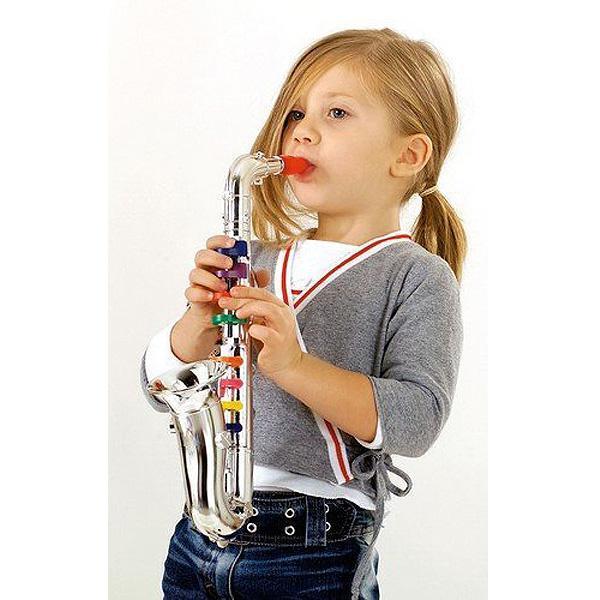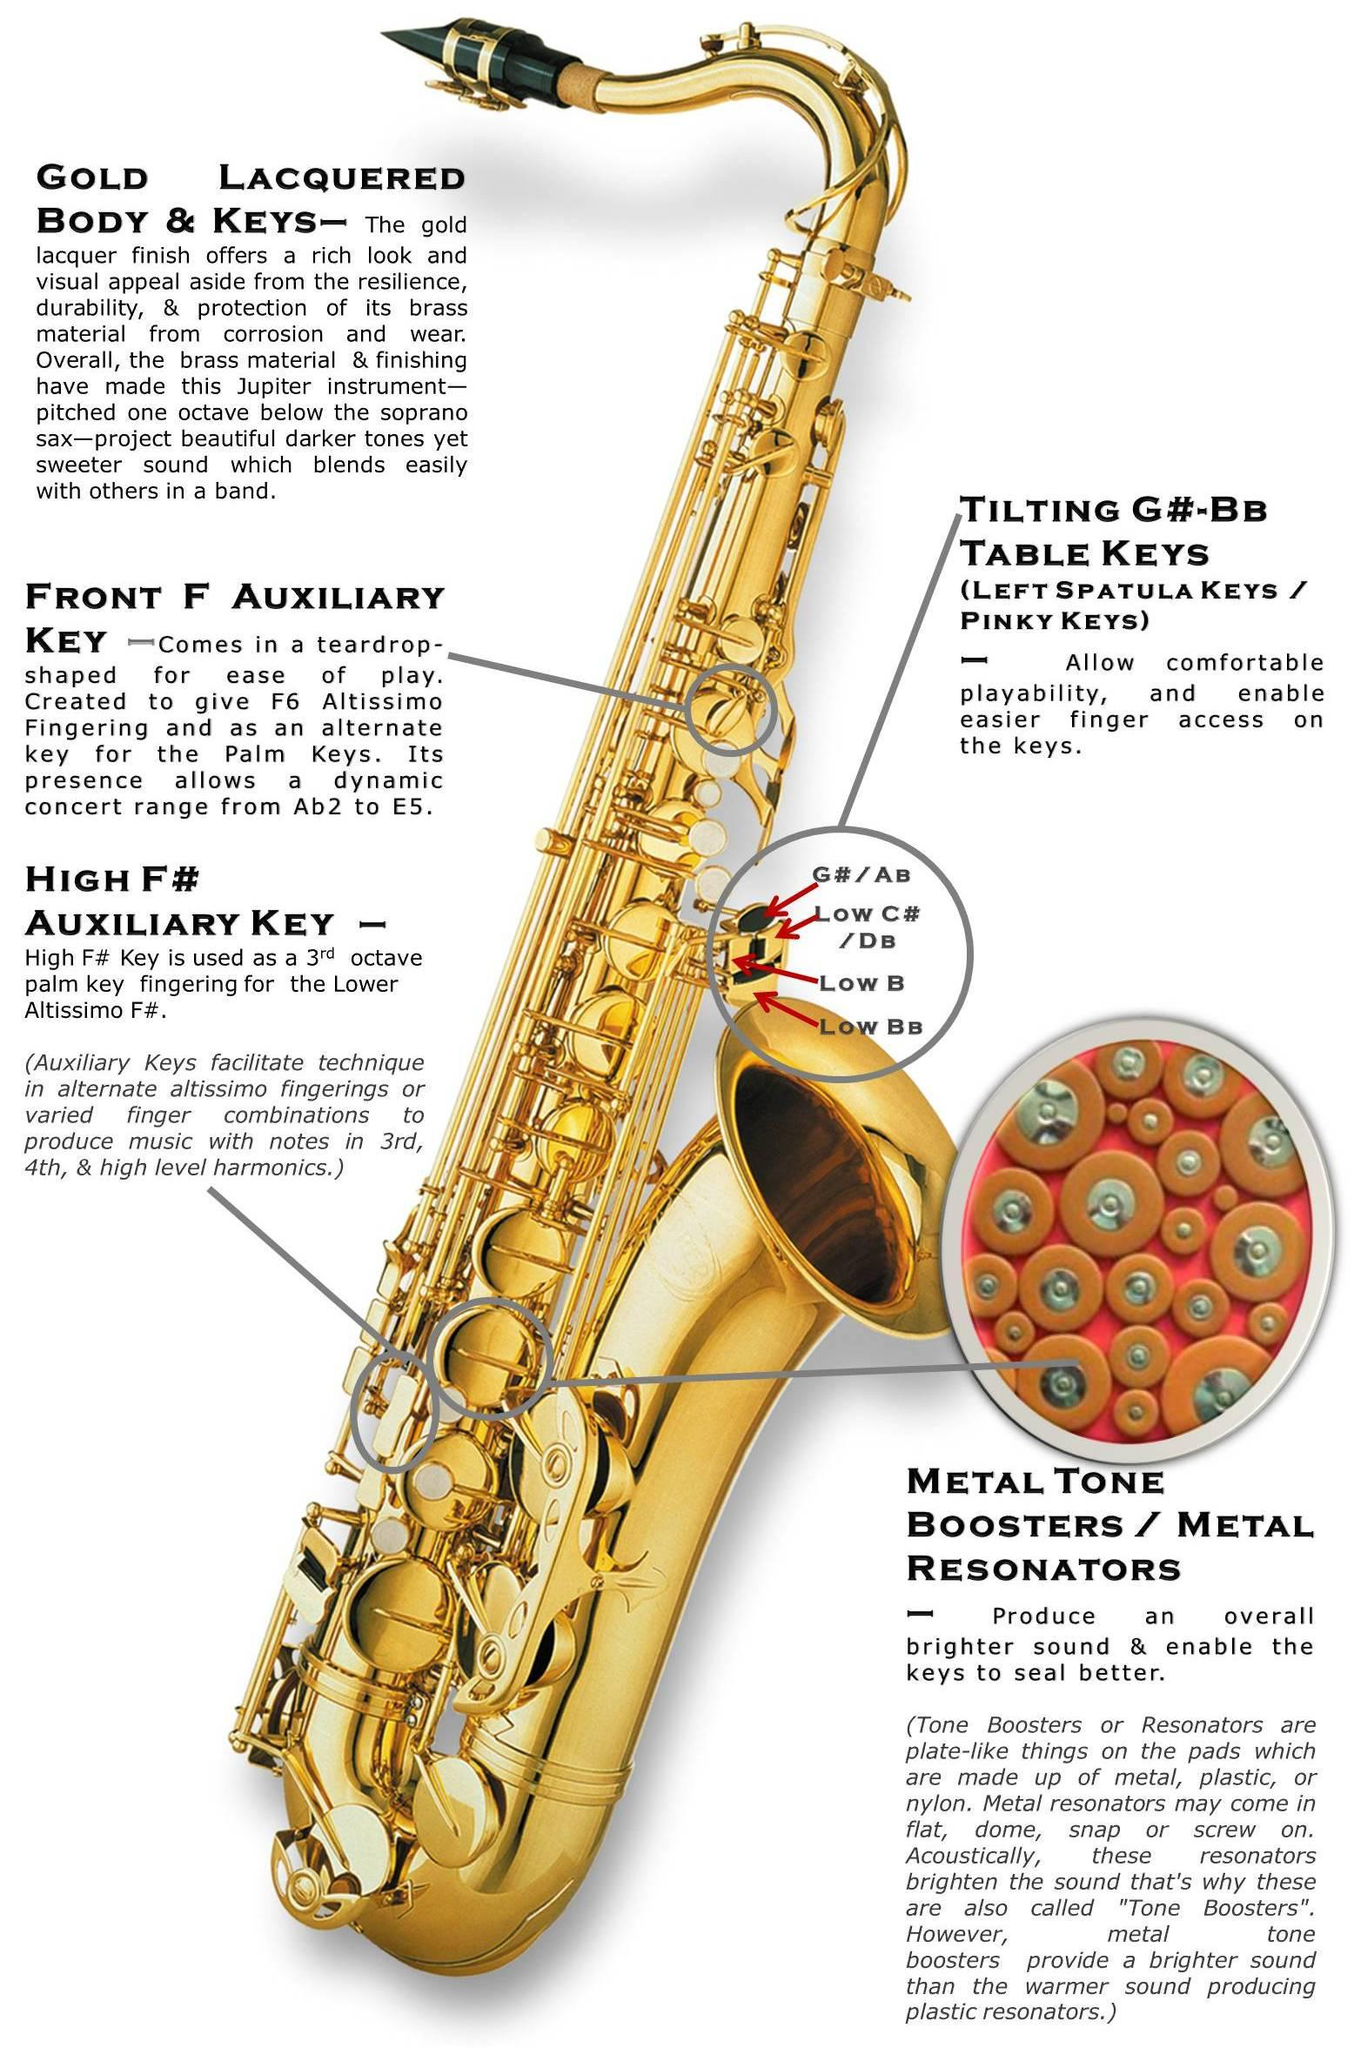The first image is the image on the left, the second image is the image on the right. Evaluate the accuracy of this statement regarding the images: "In one image, a child wearing jeans is leaning back as he or she plays a saxophone.". Is it true? Answer yes or no. Yes. The first image is the image on the left, the second image is the image on the right. Analyze the images presented: Is the assertion "In one of the images there is a child playing a saxophone." valid? Answer yes or no. Yes. 